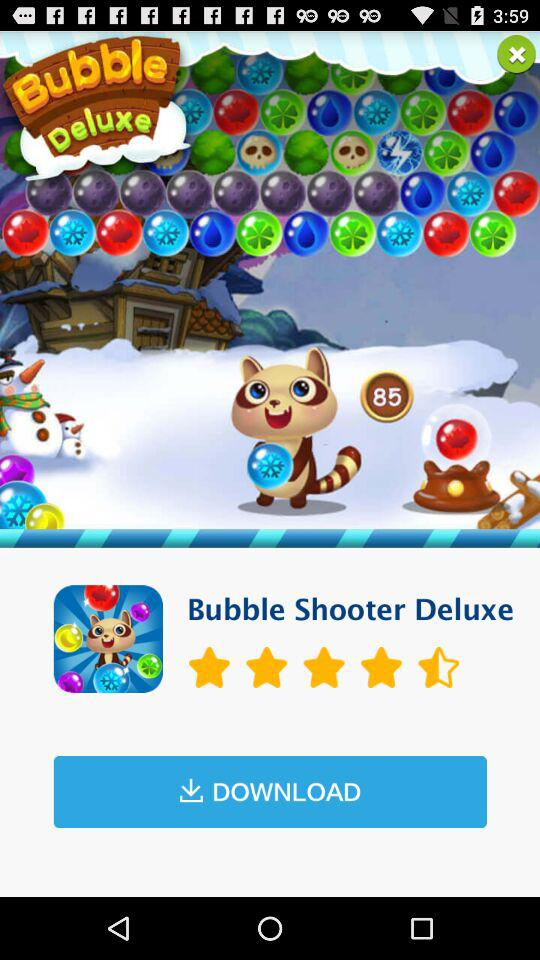What is the application name? The application name is "Bubble Shooter Deluxe". 